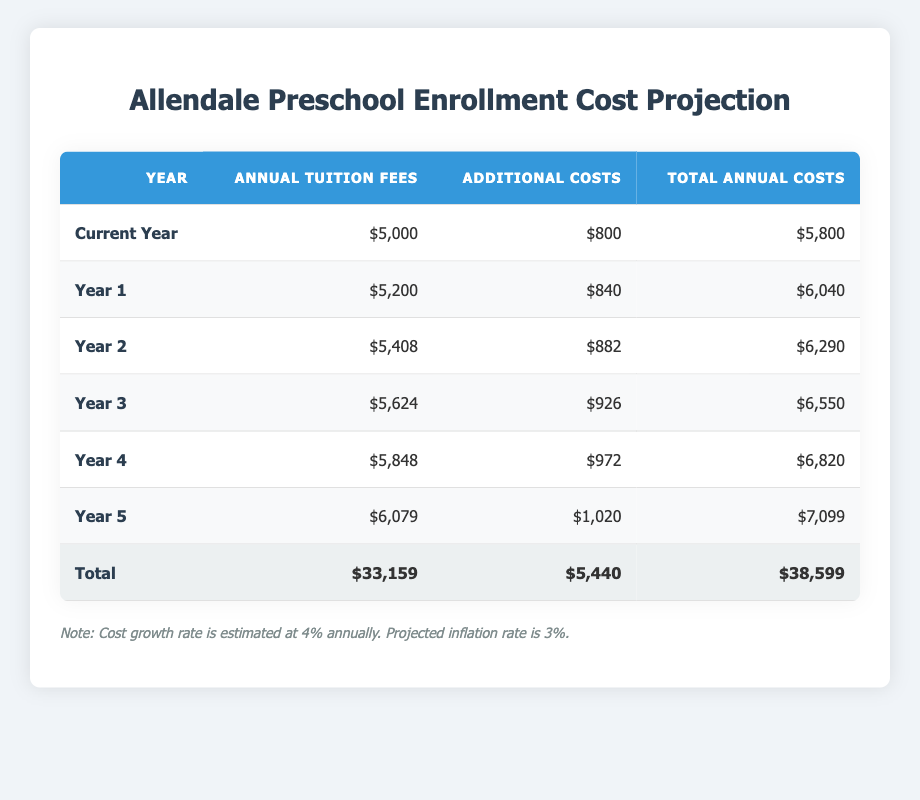What is the total annual cost for Year 3? The table shows that the total annual costs for Year 3 is listed right in the Total Annual Costs column. It states that the total annual costs for Year 3 is $6,550.
Answer: 6,550 What will the additional costs be in Year 5? According to the table under the Additional Costs column for Year 5, the additional costs are shown as $1,020.
Answer: 1,020 Is the annual tuition fee for Year 2 greater than that of Year 1? The annual tuition fee for Year 2 is $5,408, while for Year 1 it is $5,200. Since $5,408 is greater than $5,200, the statement is true.
Answer: Yes What is the total projected cost over the next five years? To find the total projected cost, we need to sum up the total annual costs from Year 1 to Year 5 along with the current year. Adding up these values gives: $5,800 + $6,040 + $6,290 + $6,550 + $6,820 + $7,099 = $38,599.
Answer: 38,599 What is the average annual tuition fee over the next 5 years? The annual tuition fees for the next 5 years can be summed: $5,200 + $5,408 + $5,624 + $5,848 + $6,079 = $28,159. To find the average, divide by 5: $28,159 / 5 = $5,631.80.
Answer: 5,631.80 How much will total annual costs increase from the current year to Year 4? The total annual cost for the current year is $5,800 and for Year 4 it is $6,820. To find the increase, subtract the current year cost from Year 4 cost: $6,820 - $5,800 = $1,020.
Answer: 1,020 Is the cost growth rate higher than the projected inflation rate? The cost growth rate is noted as 4%, while the projected inflation rate is 3%. Since 4% is indeed greater than 3%, the statement is true.
Answer: Yes What is the difference in total annual costs between Year 1 and Year 2? The total annual cost in Year 1 is $6,040, and in Year 2 it is $6,290. To find the difference, calculate: $6,290 - $6,040 = $250.
Answer: 250 